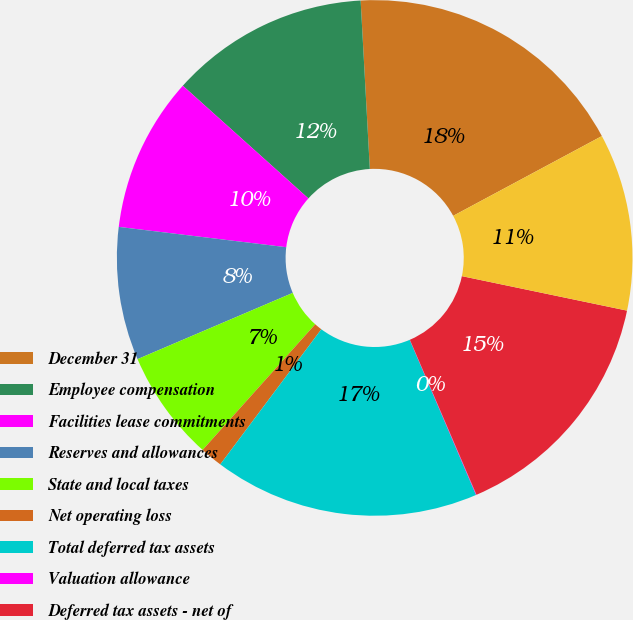Convert chart to OTSL. <chart><loc_0><loc_0><loc_500><loc_500><pie_chart><fcel>December 31<fcel>Employee compensation<fcel>Facilities lease commitments<fcel>Reserves and allowances<fcel>State and local taxes<fcel>Net operating loss<fcel>Total deferred tax assets<fcel>Valuation allowance<fcel>Deferred tax assets - net of<fcel>Depreciation and amortization<nl><fcel>18.03%<fcel>12.49%<fcel>9.72%<fcel>8.34%<fcel>6.95%<fcel>1.41%<fcel>16.65%<fcel>0.03%<fcel>15.26%<fcel>11.11%<nl></chart> 